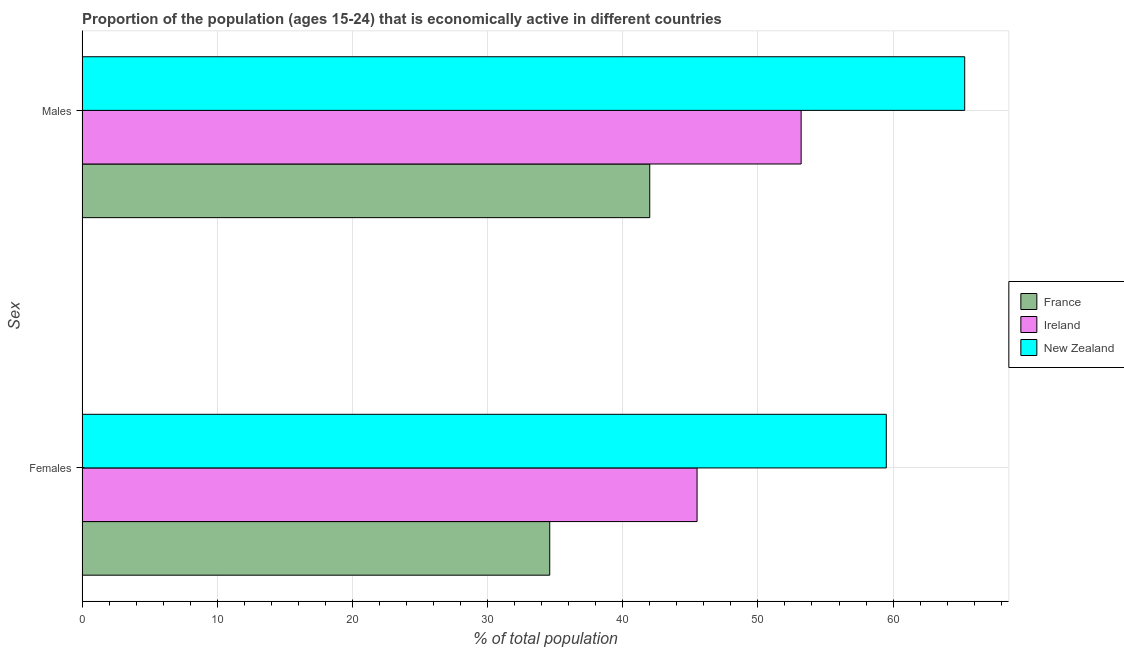How many bars are there on the 1st tick from the bottom?
Give a very brief answer. 3. What is the label of the 2nd group of bars from the top?
Your response must be concise. Females. What is the percentage of economically active female population in Ireland?
Offer a very short reply. 45.5. Across all countries, what is the maximum percentage of economically active male population?
Your answer should be compact. 65.3. Across all countries, what is the minimum percentage of economically active male population?
Your response must be concise. 42. In which country was the percentage of economically active male population maximum?
Give a very brief answer. New Zealand. What is the total percentage of economically active male population in the graph?
Make the answer very short. 160.5. What is the difference between the percentage of economically active male population in France and that in New Zealand?
Offer a very short reply. -23.3. What is the difference between the percentage of economically active male population in New Zealand and the percentage of economically active female population in Ireland?
Make the answer very short. 19.8. What is the average percentage of economically active male population per country?
Your answer should be very brief. 53.5. What is the difference between the percentage of economically active male population and percentage of economically active female population in Ireland?
Provide a succinct answer. 7.7. What is the ratio of the percentage of economically active female population in Ireland to that in France?
Your answer should be very brief. 1.32. In how many countries, is the percentage of economically active male population greater than the average percentage of economically active male population taken over all countries?
Provide a short and direct response. 1. What does the 2nd bar from the bottom in Males represents?
Your response must be concise. Ireland. What is the difference between two consecutive major ticks on the X-axis?
Offer a terse response. 10. How many legend labels are there?
Ensure brevity in your answer.  3. How are the legend labels stacked?
Keep it short and to the point. Vertical. What is the title of the graph?
Make the answer very short. Proportion of the population (ages 15-24) that is economically active in different countries. Does "Switzerland" appear as one of the legend labels in the graph?
Make the answer very short. No. What is the label or title of the X-axis?
Your answer should be compact. % of total population. What is the label or title of the Y-axis?
Ensure brevity in your answer.  Sex. What is the % of total population in France in Females?
Give a very brief answer. 34.6. What is the % of total population in Ireland in Females?
Keep it short and to the point. 45.5. What is the % of total population in New Zealand in Females?
Your response must be concise. 59.5. What is the % of total population of Ireland in Males?
Keep it short and to the point. 53.2. What is the % of total population of New Zealand in Males?
Ensure brevity in your answer.  65.3. Across all Sex, what is the maximum % of total population in Ireland?
Your response must be concise. 53.2. Across all Sex, what is the maximum % of total population of New Zealand?
Your answer should be very brief. 65.3. Across all Sex, what is the minimum % of total population of France?
Your answer should be very brief. 34.6. Across all Sex, what is the minimum % of total population in Ireland?
Provide a short and direct response. 45.5. Across all Sex, what is the minimum % of total population of New Zealand?
Your response must be concise. 59.5. What is the total % of total population in France in the graph?
Your response must be concise. 76.6. What is the total % of total population in Ireland in the graph?
Provide a succinct answer. 98.7. What is the total % of total population in New Zealand in the graph?
Offer a terse response. 124.8. What is the difference between the % of total population of France in Females and that in Males?
Offer a terse response. -7.4. What is the difference between the % of total population in France in Females and the % of total population in Ireland in Males?
Offer a very short reply. -18.6. What is the difference between the % of total population of France in Females and the % of total population of New Zealand in Males?
Offer a very short reply. -30.7. What is the difference between the % of total population of Ireland in Females and the % of total population of New Zealand in Males?
Offer a very short reply. -19.8. What is the average % of total population in France per Sex?
Provide a succinct answer. 38.3. What is the average % of total population in Ireland per Sex?
Your answer should be very brief. 49.35. What is the average % of total population in New Zealand per Sex?
Ensure brevity in your answer.  62.4. What is the difference between the % of total population in France and % of total population in Ireland in Females?
Your answer should be very brief. -10.9. What is the difference between the % of total population in France and % of total population in New Zealand in Females?
Ensure brevity in your answer.  -24.9. What is the difference between the % of total population in France and % of total population in New Zealand in Males?
Your answer should be very brief. -23.3. What is the ratio of the % of total population in France in Females to that in Males?
Offer a very short reply. 0.82. What is the ratio of the % of total population of Ireland in Females to that in Males?
Ensure brevity in your answer.  0.86. What is the ratio of the % of total population of New Zealand in Females to that in Males?
Your answer should be compact. 0.91. What is the difference between the highest and the second highest % of total population in Ireland?
Offer a terse response. 7.7. What is the difference between the highest and the lowest % of total population of France?
Keep it short and to the point. 7.4. What is the difference between the highest and the lowest % of total population of New Zealand?
Your answer should be very brief. 5.8. 